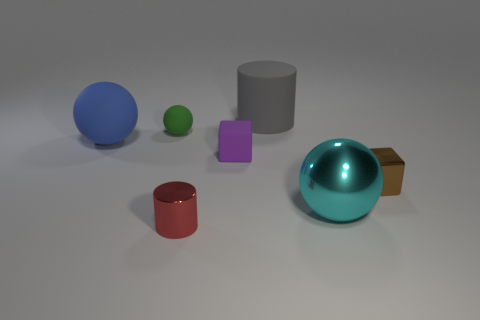Add 3 big blue matte things. How many objects exist? 10 Subtract all blocks. How many objects are left? 5 Add 7 cyan metal balls. How many cyan metal balls exist? 8 Subtract 0 yellow cylinders. How many objects are left? 7 Subtract all shiny cubes. Subtract all metal cylinders. How many objects are left? 5 Add 4 matte cubes. How many matte cubes are left? 5 